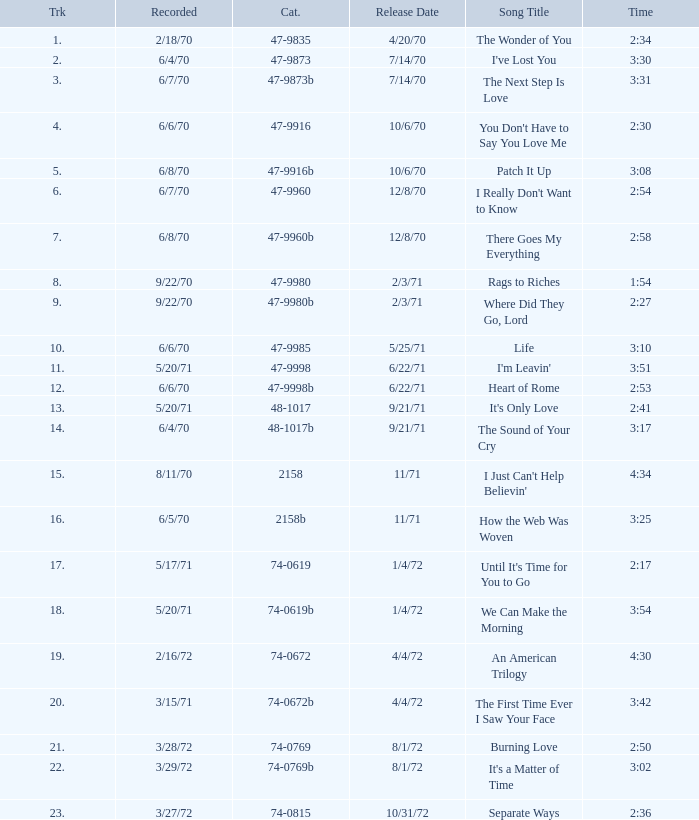What is the catalogue number for the song that is 3:17 and was released 9/21/71? 48-1017b. 